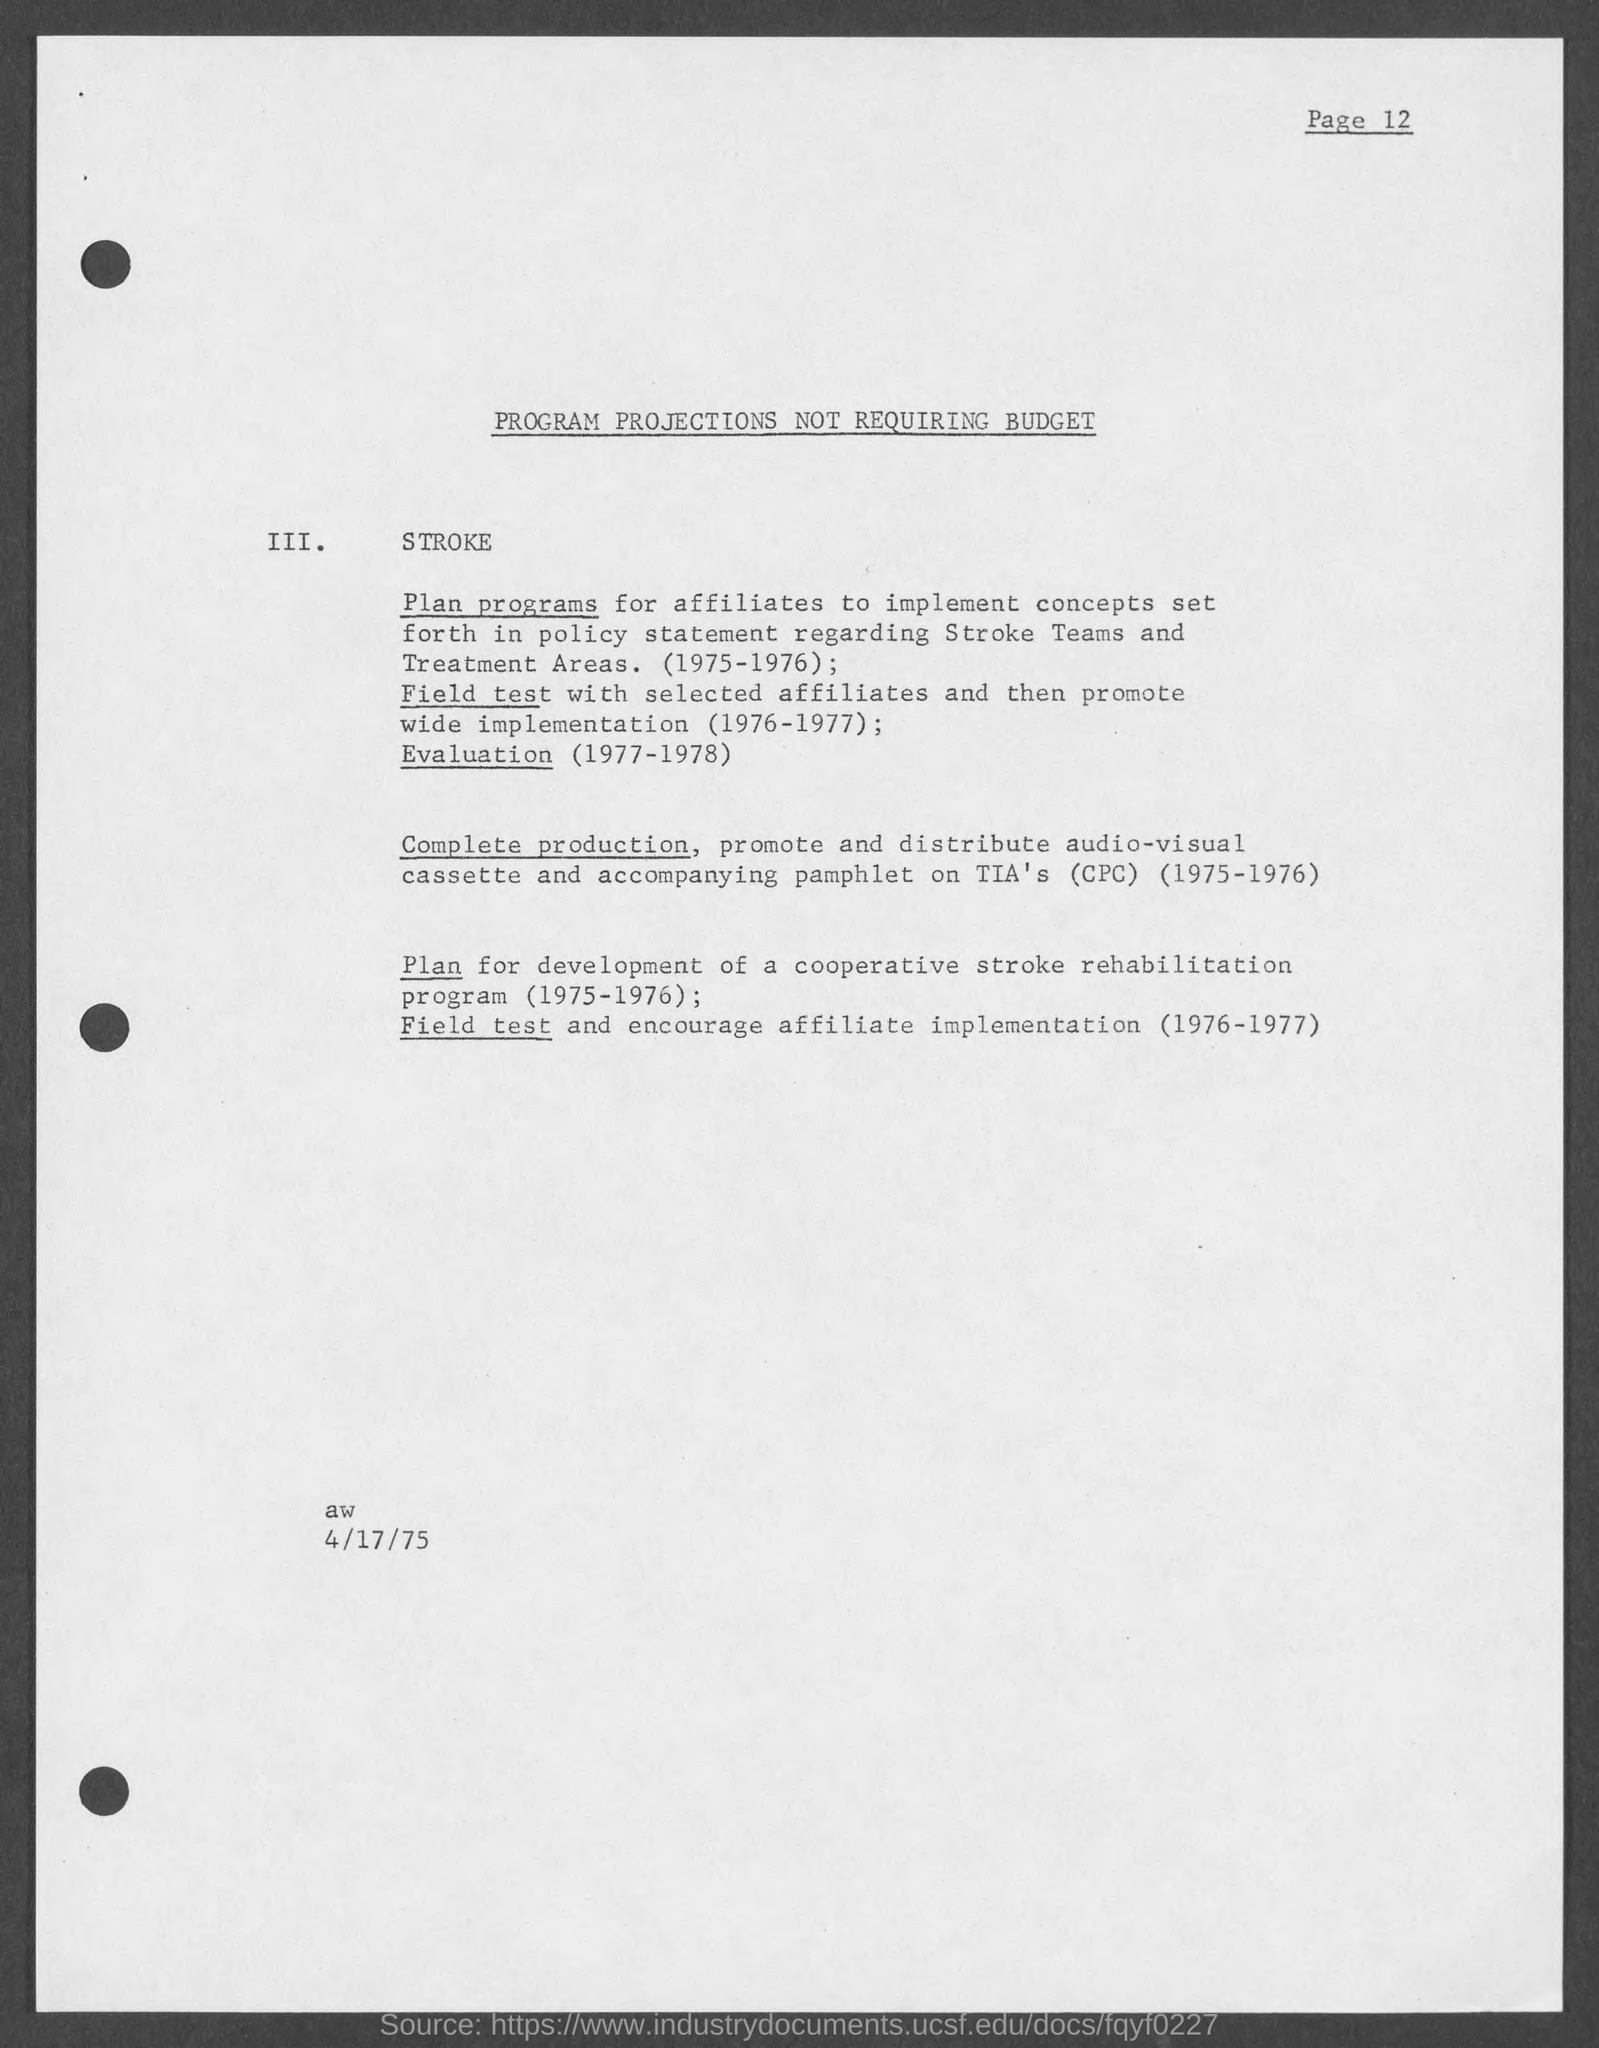Point out several critical features in this image. The document title is 'PROGRAM PROJECTIONS NOT REQUIRING BUDGET.' The document is dated April 17, 1975. 